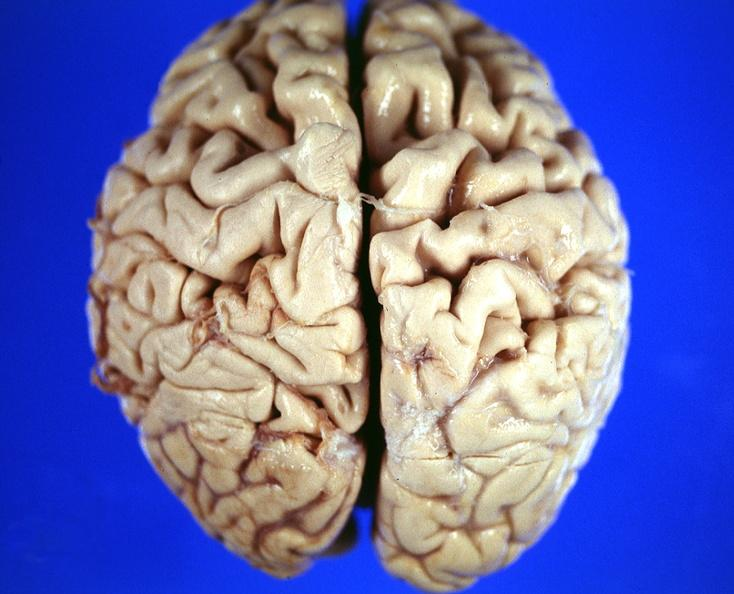s chronic myelogenous leukemia in blast crisis present?
Answer the question using a single word or phrase. No 